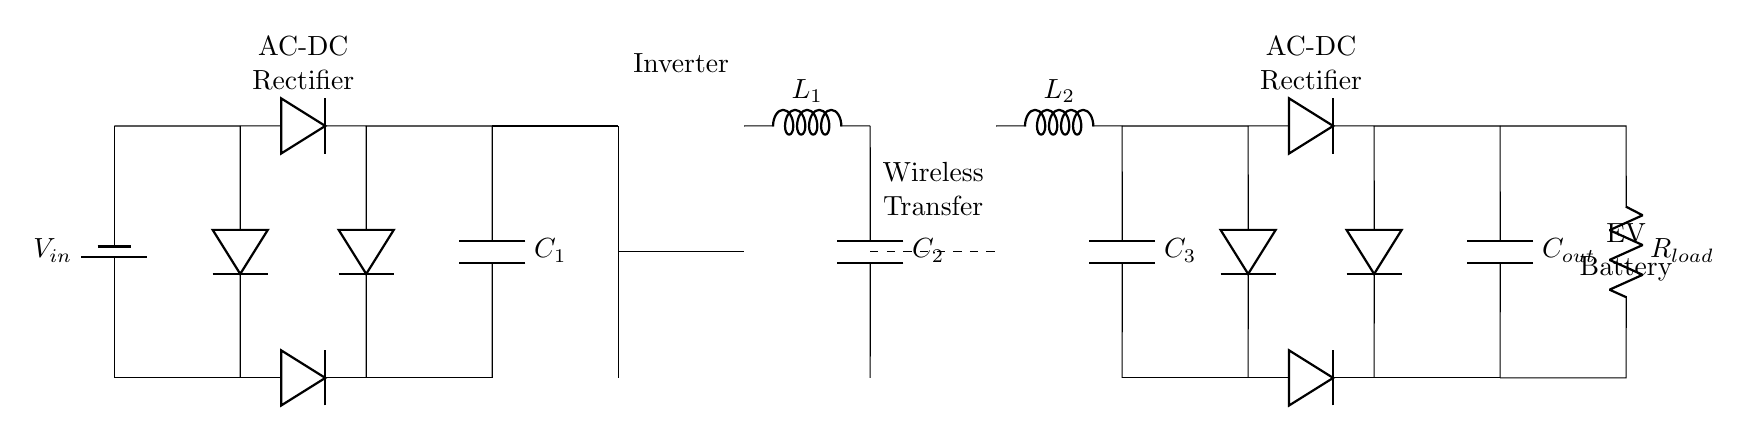What type of circuit is displayed in this diagram? The circuit represents a wireless charging circuit designed for electric vehicle parking stations, indicated by components like inductors and capacitors that are characteristic of resonant circuits.
Answer: Wireless charging circuit What components are used to rectify the AC voltage in this circuit? AC voltage is rectified by four diodes arranged in two pairs, allowing current to flow during both halves of the AC cycle. This information can be observed in the sections labeled as rectifiers in the diagram.
Answer: Diodes What is the role of the transformer in this circuit? The transformer is used to step-up or step-down the voltage as required for efficient wireless power transfer. It connects the primary and secondary inductors and is essential for adjusting the voltage levels for wireless charging.
Answer: Voltage adjustment How many capacitors are in the circuit? The circuit contains four capacitors labeled as C1, C2, C3, and Cout, serving various functions like smoothing and energy storage in both the rectification and output stages.
Answer: Four capacitors What frequency does the resonant circuit operate at? The resonant frequency is typically determined by the values of the inductors L1 and L2 and capacitors C2 and C3, though exact values are not specified in this diagram and would depend on the component specifications.
Answer: Variable (not specified) How does wireless power transfer occur between the charging coil and the EV? Wireless power transfer occurs through magnetic coupling between the two inductors L1 and L2, where an oscillating magnetic field from L1 induces a current in L2, transferring energy without direct electrical connection.
Answer: Magnetic coupling What is the load represented in this circuit? The load is represented by the resistor labeled as Rload, which simulates the electric vehicle's battery charging process, indicating how the energy from the circuit is utilized.
Answer: Electric vehicle battery 